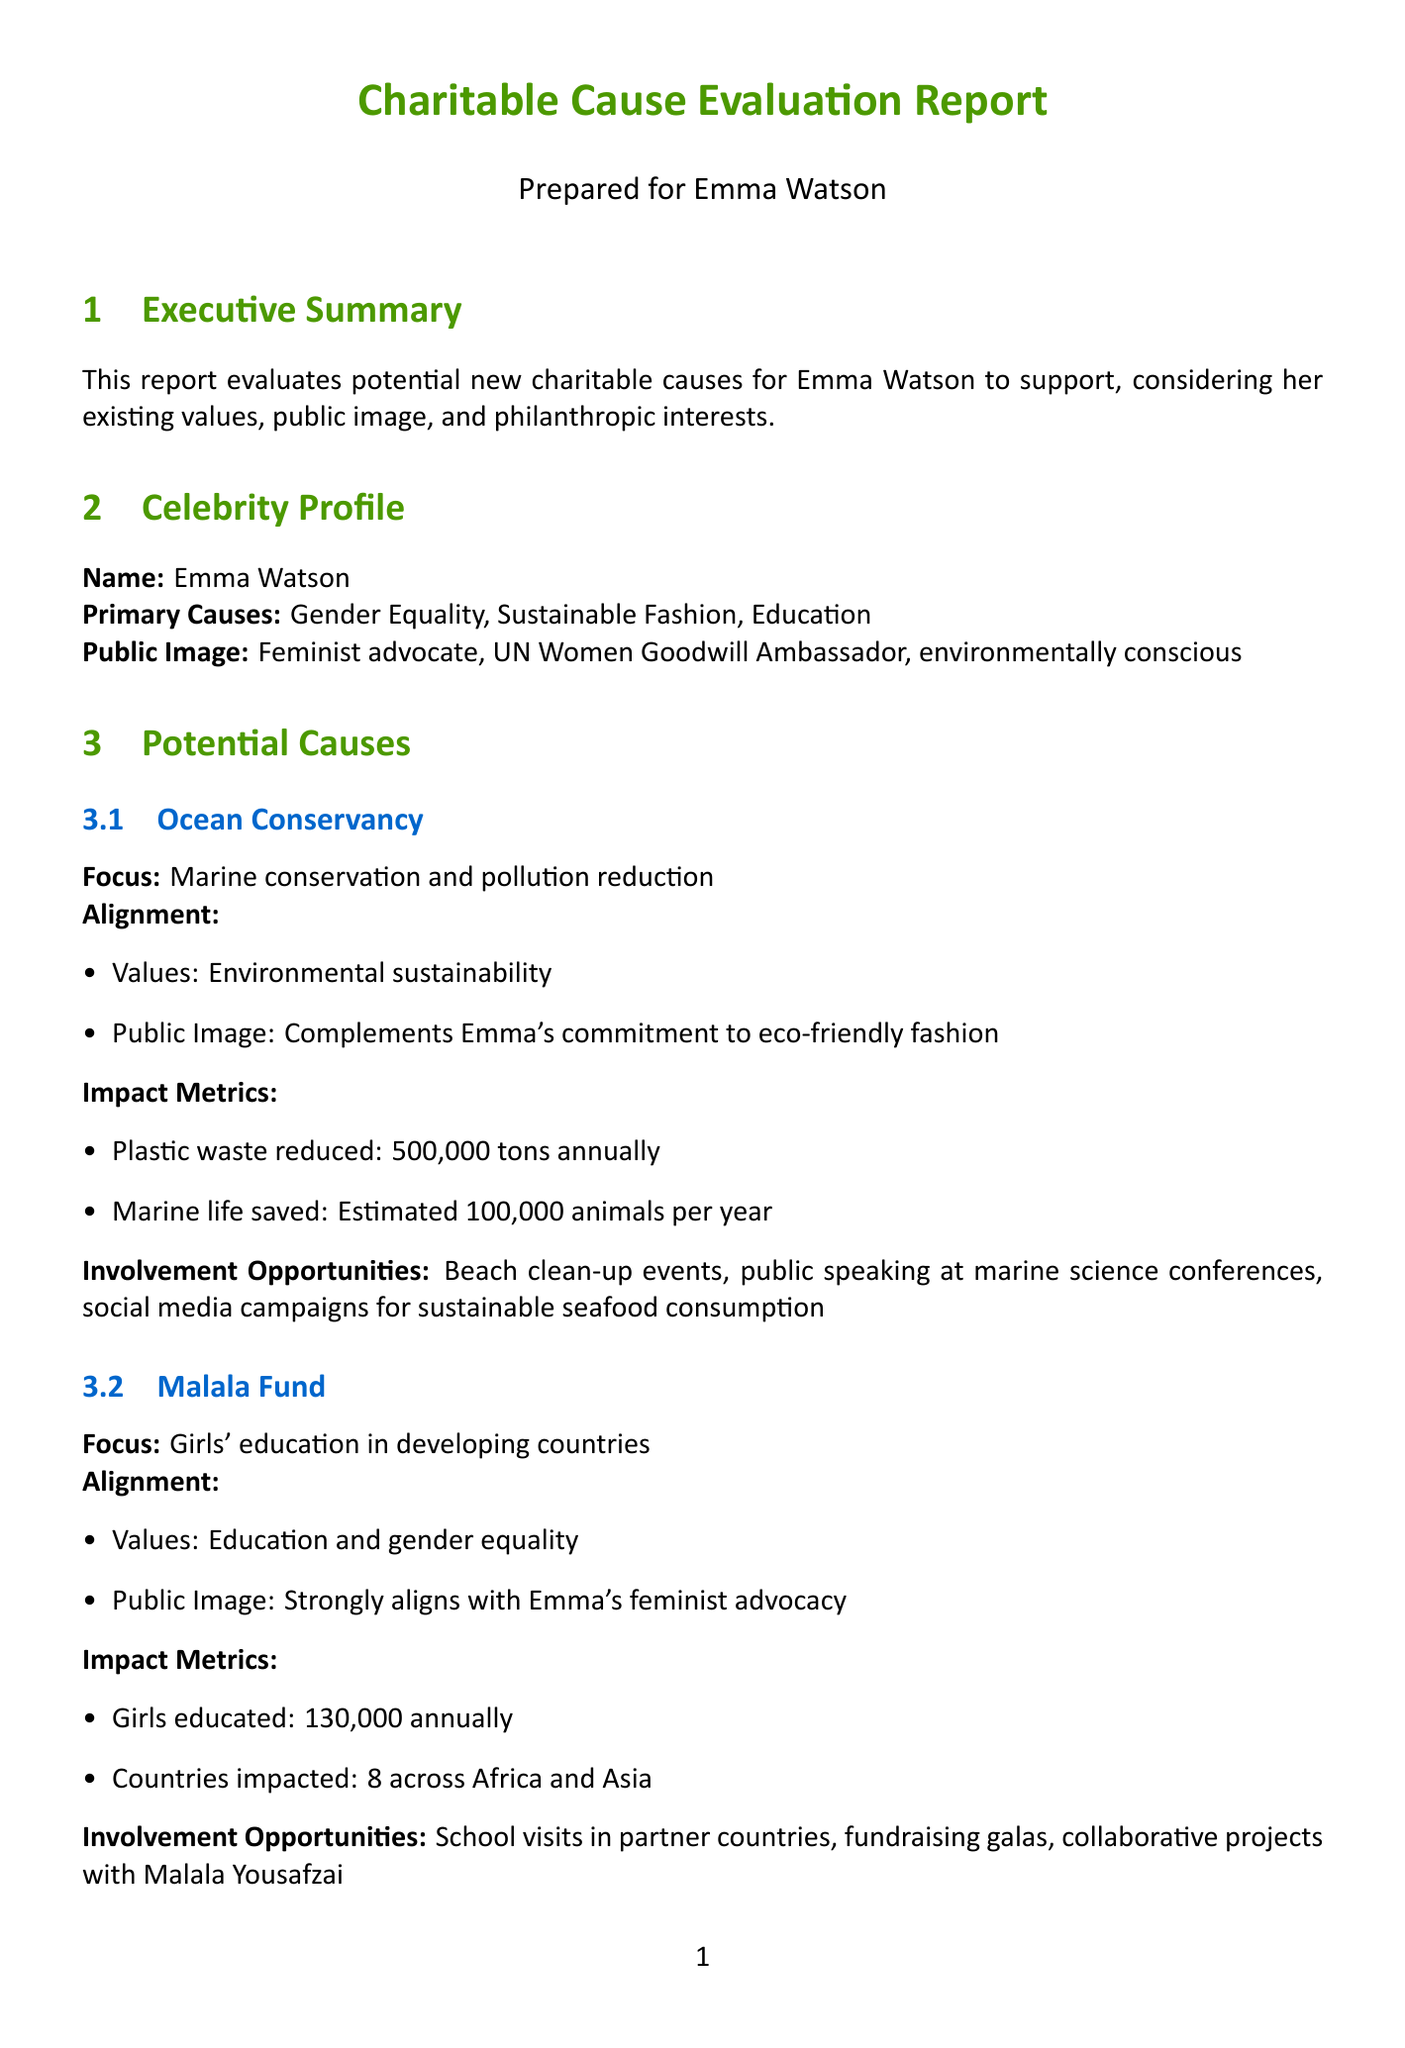What are Emma Watson's primary causes? The document lists Emma Watson's primary causes as gender equality, sustainable fashion, and education.
Answer: Gender Equality, Sustainable Fashion, Education What is the focus of Ocean Conservancy? The Ocean Conservancy's focus is on marine conservation and pollution reduction.
Answer: Marine conservation and pollution reduction How many girls does the Malala Fund educate annually? The document states that the Malala Fund educates 130,000 girls annually.
Answer: 130,000 What impact metric does The Hunger Project list for people reached? The Hunger Project claims to have reached 16 million people across 13 countries.
Answer: 16 million What is one fundraising strategy mentioned in the document? The document includes charity gala dinner, social media challenge, and limited edition merchandise as fundraising strategies.
Answer: Charity Gala Dinner Which organization has a public image that aligns with Emma's feminist advocacy? The Malala Fund's public image is strongly aligned with Emma Watson's feminist advocacy.
Answer: Malala Fund What is the estimated revenue for the Charity Gala Dinner? The estimated revenue for the Charity Gala Dinner is between $500,000 to $750,000.
Answer: $500,000 - $750,000 What should be balanced according to long-term considerations? The long-term considerations document states the need to balance time commitments between acting career and philanthropy.
Answer: Time commitments between acting career and philanthropy 